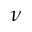<formula> <loc_0><loc_0><loc_500><loc_500>\nu</formula> 